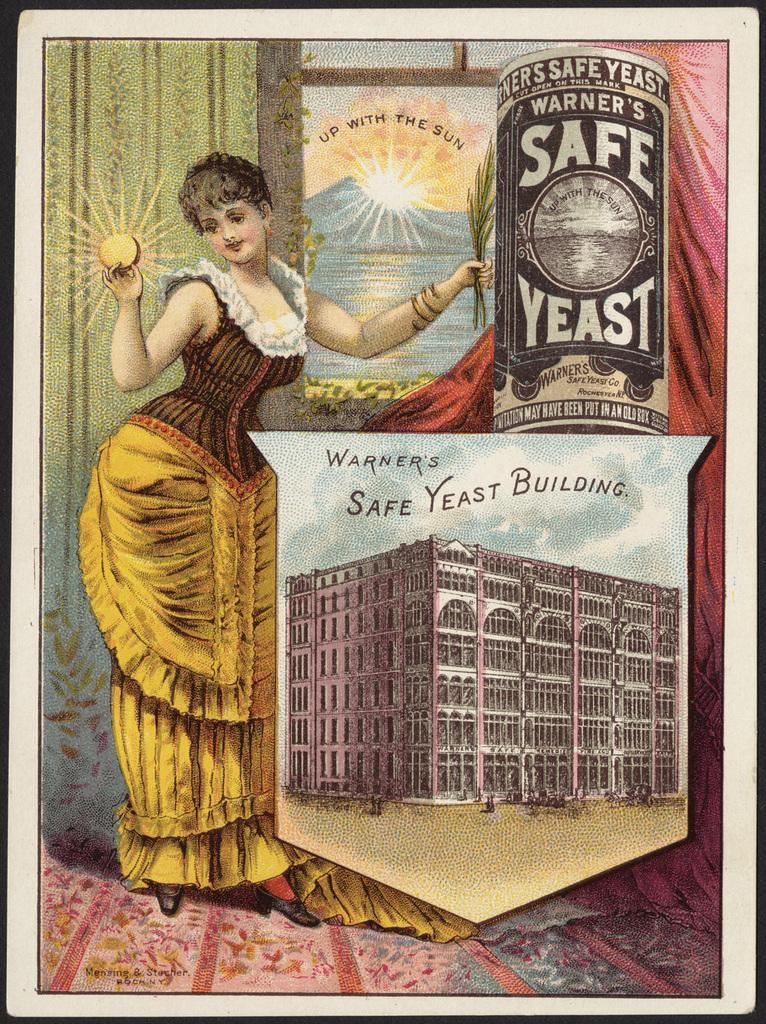Provide a one-sentence caption for the provided image. A lady in a dress is posing with Warner's Safe Yeast and holding a sun in her right hand. 